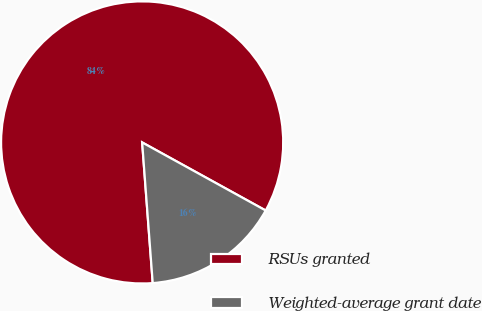Convert chart. <chart><loc_0><loc_0><loc_500><loc_500><pie_chart><fcel>RSUs granted<fcel>Weighted-average grant date<nl><fcel>84.21%<fcel>15.79%<nl></chart> 